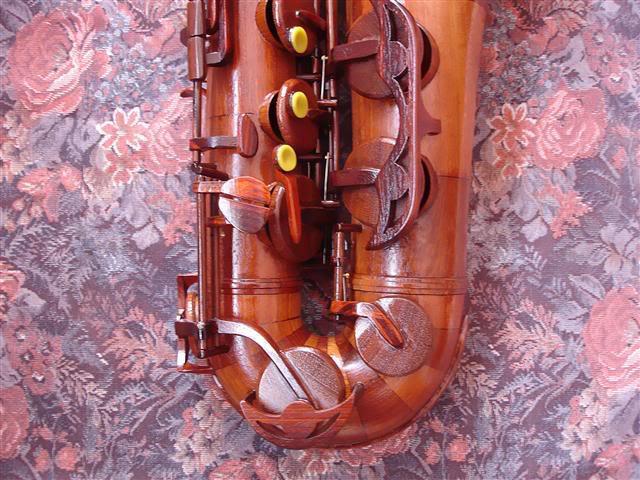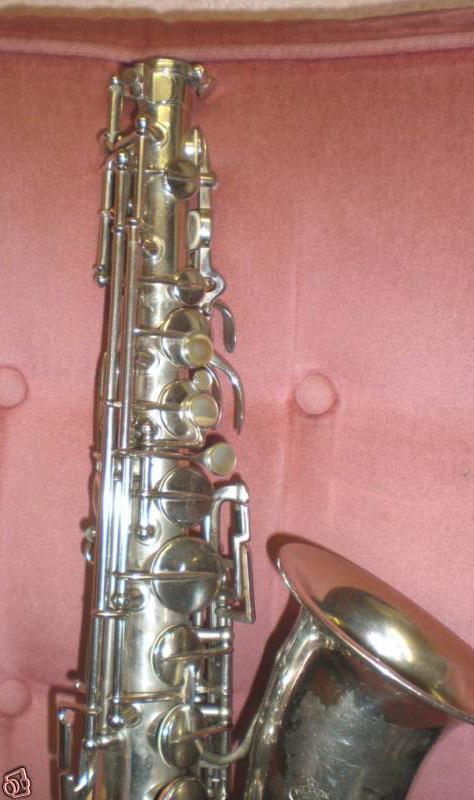The first image is the image on the left, the second image is the image on the right. Given the left and right images, does the statement "At least one image shows a saxophone displayed on a rich orange-red fabric." hold true? Answer yes or no. No. The first image is the image on the left, the second image is the image on the right. Analyze the images presented: Is the assertion "The image on the right features a silver sax in the upright position." valid? Answer yes or no. Yes. 